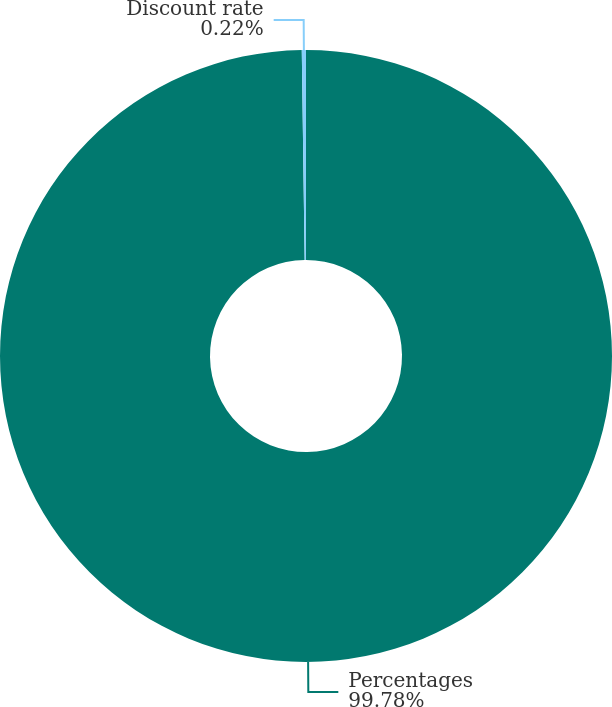<chart> <loc_0><loc_0><loc_500><loc_500><pie_chart><fcel>Percentages<fcel>Discount rate<nl><fcel>99.78%<fcel>0.22%<nl></chart> 